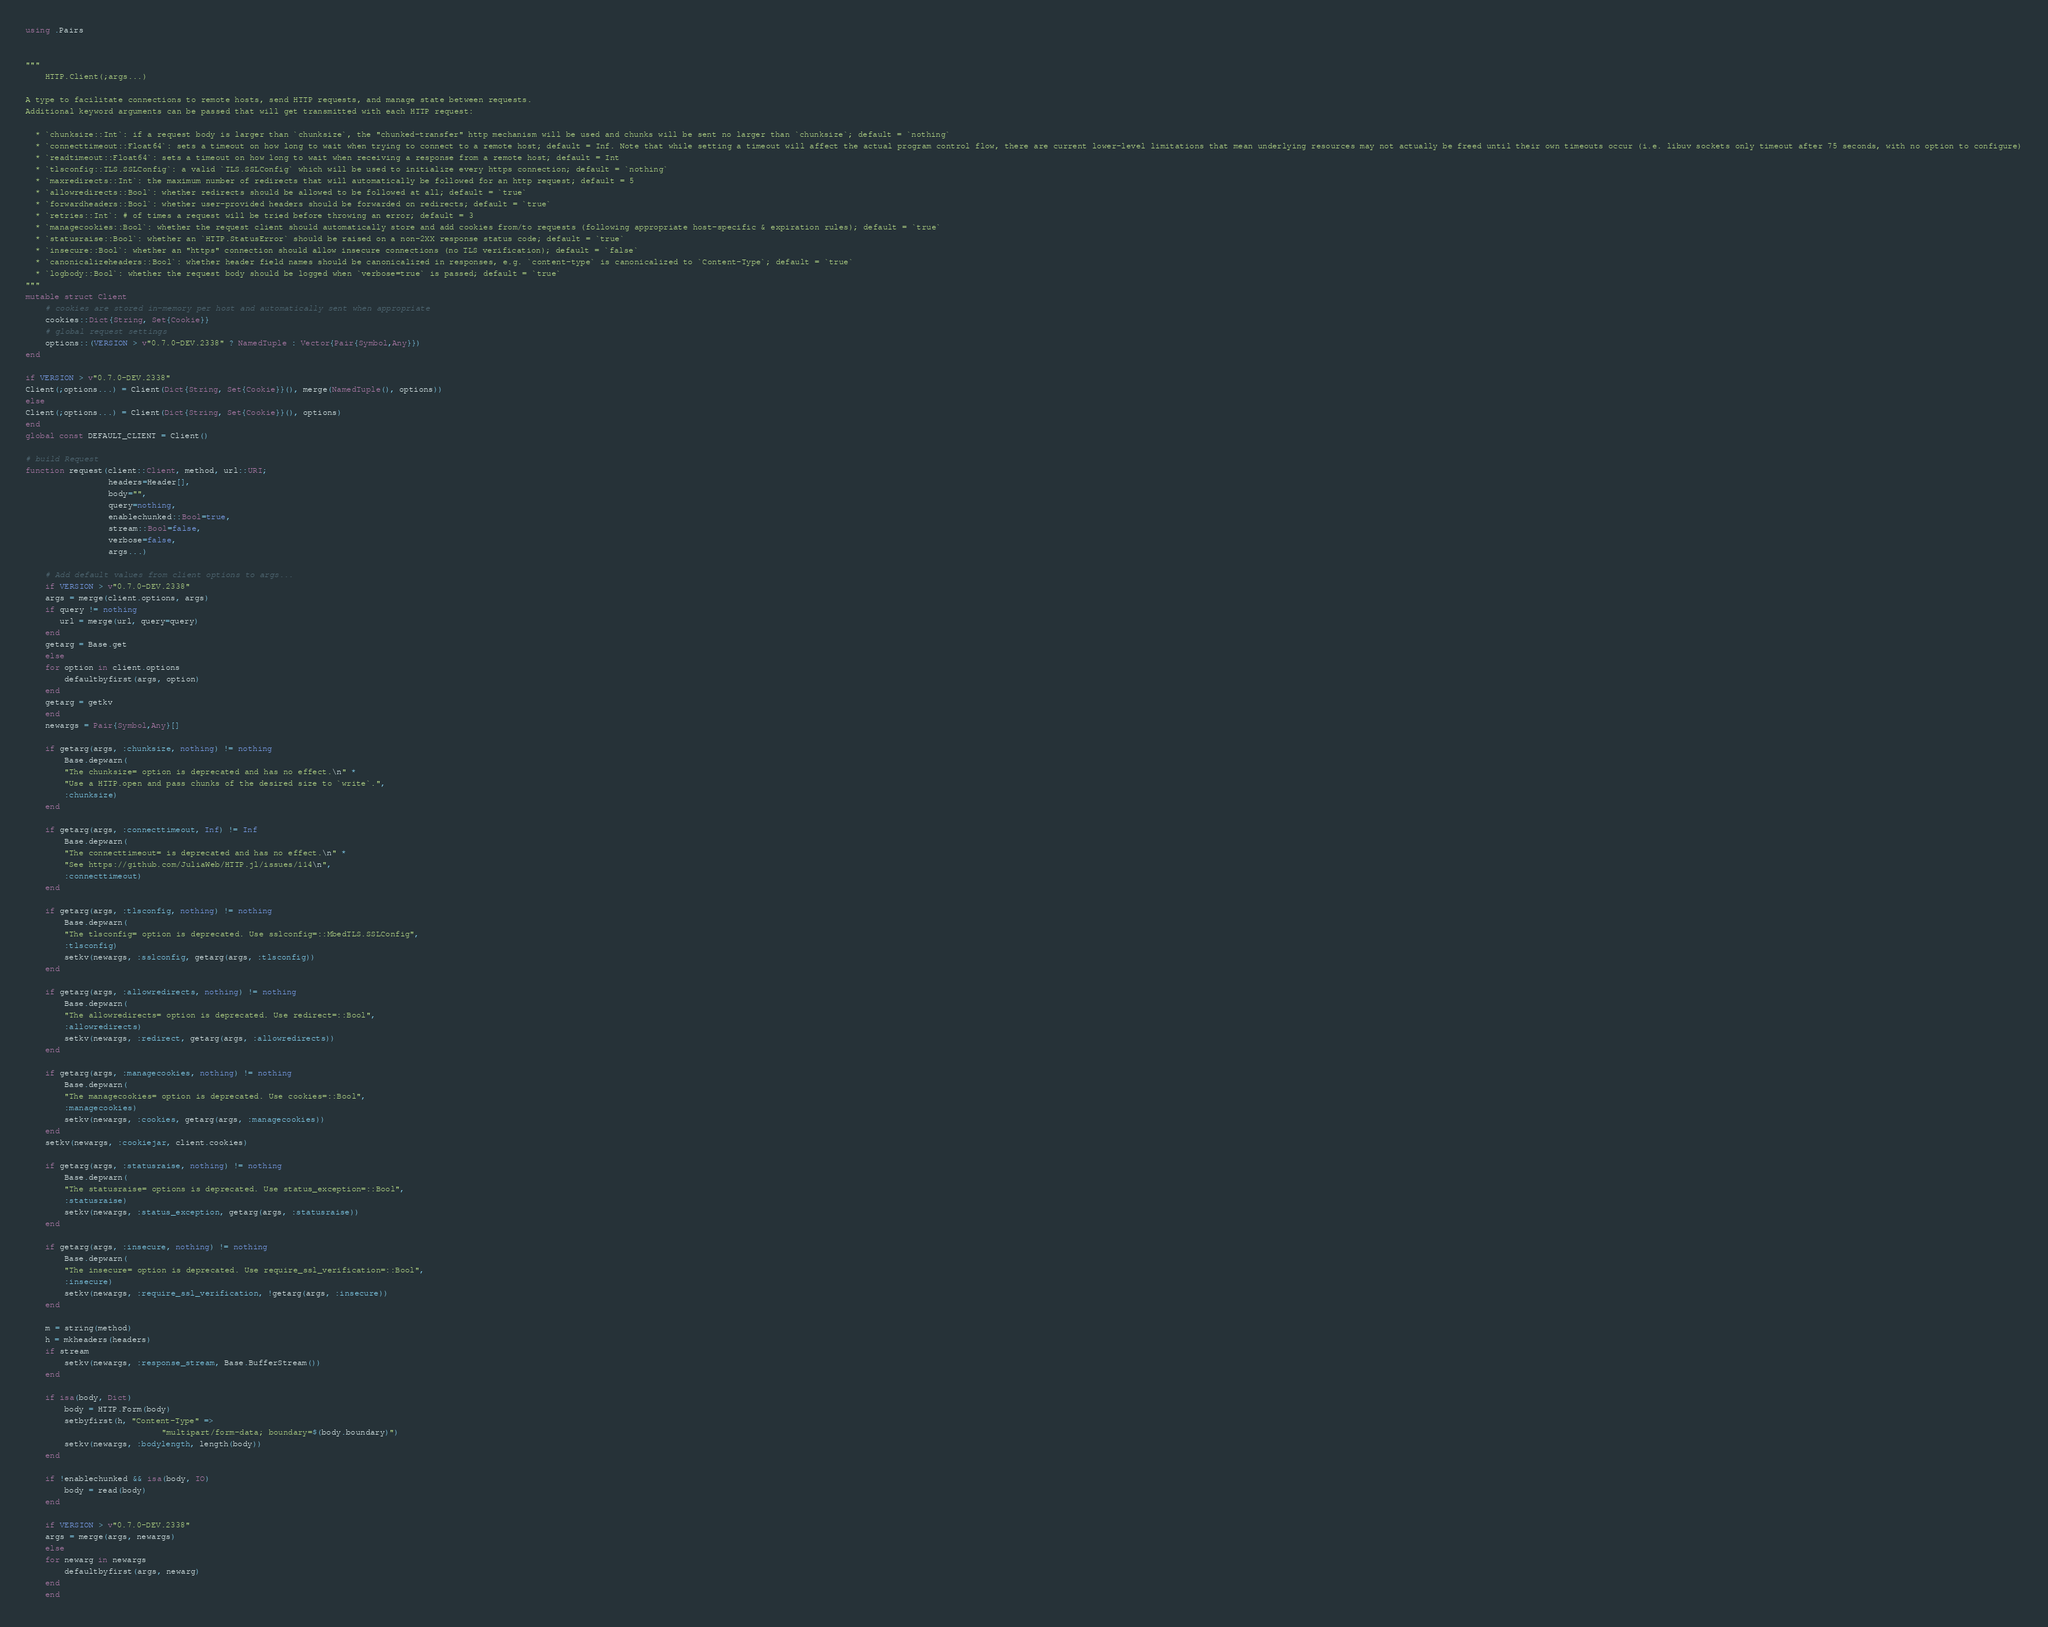Convert code to text. <code><loc_0><loc_0><loc_500><loc_500><_Julia_>using .Pairs


"""
    HTTP.Client(;args...)

A type to facilitate connections to remote hosts, send HTTP requests, and manage state between requests.
Additional keyword arguments can be passed that will get transmitted with each HTTP request:

  * `chunksize::Int`: if a request body is larger than `chunksize`, the "chunked-transfer" http mechanism will be used and chunks will be sent no larger than `chunksize`; default = `nothing`
  * `connecttimeout::Float64`: sets a timeout on how long to wait when trying to connect to a remote host; default = Inf. Note that while setting a timeout will affect the actual program control flow, there are current lower-level limitations that mean underlying resources may not actually be freed until their own timeouts occur (i.e. libuv sockets only timeout after 75 seconds, with no option to configure)
  * `readtimeout::Float64`: sets a timeout on how long to wait when receiving a response from a remote host; default = Int
  * `tlsconfig::TLS.SSLConfig`: a valid `TLS.SSLConfig` which will be used to initialize every https connection; default = `nothing`
  * `maxredirects::Int`: the maximum number of redirects that will automatically be followed for an http request; default = 5
  * `allowredirects::Bool`: whether redirects should be allowed to be followed at all; default = `true`
  * `forwardheaders::Bool`: whether user-provided headers should be forwarded on redirects; default = `true`
  * `retries::Int`: # of times a request will be tried before throwing an error; default = 3
  * `managecookies::Bool`: whether the request client should automatically store and add cookies from/to requests (following appropriate host-specific & expiration rules); default = `true`
  * `statusraise::Bool`: whether an `HTTP.StatusError` should be raised on a non-2XX response status code; default = `true`
  * `insecure::Bool`: whether an "https" connection should allow insecure connections (no TLS verification); default = `false`
  * `canonicalizeheaders::Bool`: whether header field names should be canonicalized in responses, e.g. `content-type` is canonicalized to `Content-Type`; default = `true`
  * `logbody::Bool`: whether the request body should be logged when `verbose=true` is passed; default = `true`
"""
mutable struct Client
    # cookies are stored in-memory per host and automatically sent when appropriate
    cookies::Dict{String, Set{Cookie}}
    # global request settings
    options::(VERSION > v"0.7.0-DEV.2338" ? NamedTuple : Vector{Pair{Symbol,Any}})
end

if VERSION > v"0.7.0-DEV.2338"
Client(;options...) = Client(Dict{String, Set{Cookie}}(), merge(NamedTuple(), options))
else
Client(;options...) = Client(Dict{String, Set{Cookie}}(), options)
end
global const DEFAULT_CLIENT = Client()

# build Request
function request(client::Client, method, url::URI;
                 headers=Header[],
                 body="",
                 query=nothing,
                 enablechunked::Bool=true,
                 stream::Bool=false,
                 verbose=false,
                 args...)

    # Add default values from client options to args...
    if VERSION > v"0.7.0-DEV.2338"
    args = merge(client.options, args)
    if query != nothing
       url = merge(url, query=query)
    end
    getarg = Base.get
    else
    for option in client.options
        defaultbyfirst(args, option)
    end
    getarg = getkv
    end
    newargs = Pair{Symbol,Any}[]

    if getarg(args, :chunksize, nothing) != nothing
        Base.depwarn(
        "The chunksize= option is deprecated and has no effect.\n" *
        "Use a HTTP.open and pass chunks of the desired size to `write`.",
        :chunksize)
    end

    if getarg(args, :connecttimeout, Inf) != Inf
        Base.depwarn(
        "The connecttimeout= is deprecated and has no effect.\n" *
        "See https://github.com/JuliaWeb/HTTP.jl/issues/114\n",
        :connecttimeout)
    end

    if getarg(args, :tlsconfig, nothing) != nothing
        Base.depwarn(
        "The tlsconfig= option is deprecated. Use sslconfig=::MbedTLS.SSLConfig",
        :tlsconfig)
        setkv(newargs, :sslconfig, getarg(args, :tlsconfig))
    end

    if getarg(args, :allowredirects, nothing) != nothing
        Base.depwarn(
        "The allowredirects= option is deprecated. Use redirect=::Bool",
        :allowredirects)
        setkv(newargs, :redirect, getarg(args, :allowredirects))
    end

    if getarg(args, :managecookies, nothing) != nothing
        Base.depwarn(
        "The managecookies= option is deprecated. Use cookies=::Bool",
        :managecookies)
        setkv(newargs, :cookies, getarg(args, :managecookies))
    end
    setkv(newargs, :cookiejar, client.cookies)

    if getarg(args, :statusraise, nothing) != nothing
        Base.depwarn(
        "The statusraise= options is deprecated. Use status_exception=::Bool",
        :statusraise)
        setkv(newargs, :status_exception, getarg(args, :statusraise))
    end

    if getarg(args, :insecure, nothing) != nothing
        Base.depwarn(
        "The insecure= option is deprecated. Use require_ssl_verification=::Bool",
        :insecure)
        setkv(newargs, :require_ssl_verification, !getarg(args, :insecure))
    end

    m = string(method)
    h = mkheaders(headers)
    if stream
        setkv(newargs, :response_stream, Base.BufferStream())
    end

    if isa(body, Dict)
        body = HTTP.Form(body)
        setbyfirst(h, "Content-Type" =>
                            "multipart/form-data; boundary=$(body.boundary)")
        setkv(newargs, :bodylength, length(body))
    end

    if !enablechunked && isa(body, IO)
        body = read(body)
    end

    if VERSION > v"0.7.0-DEV.2338"
    args = merge(args, newargs)
    else
    for newarg in newargs
        defaultbyfirst(args, newarg)
    end
    end
</code> 